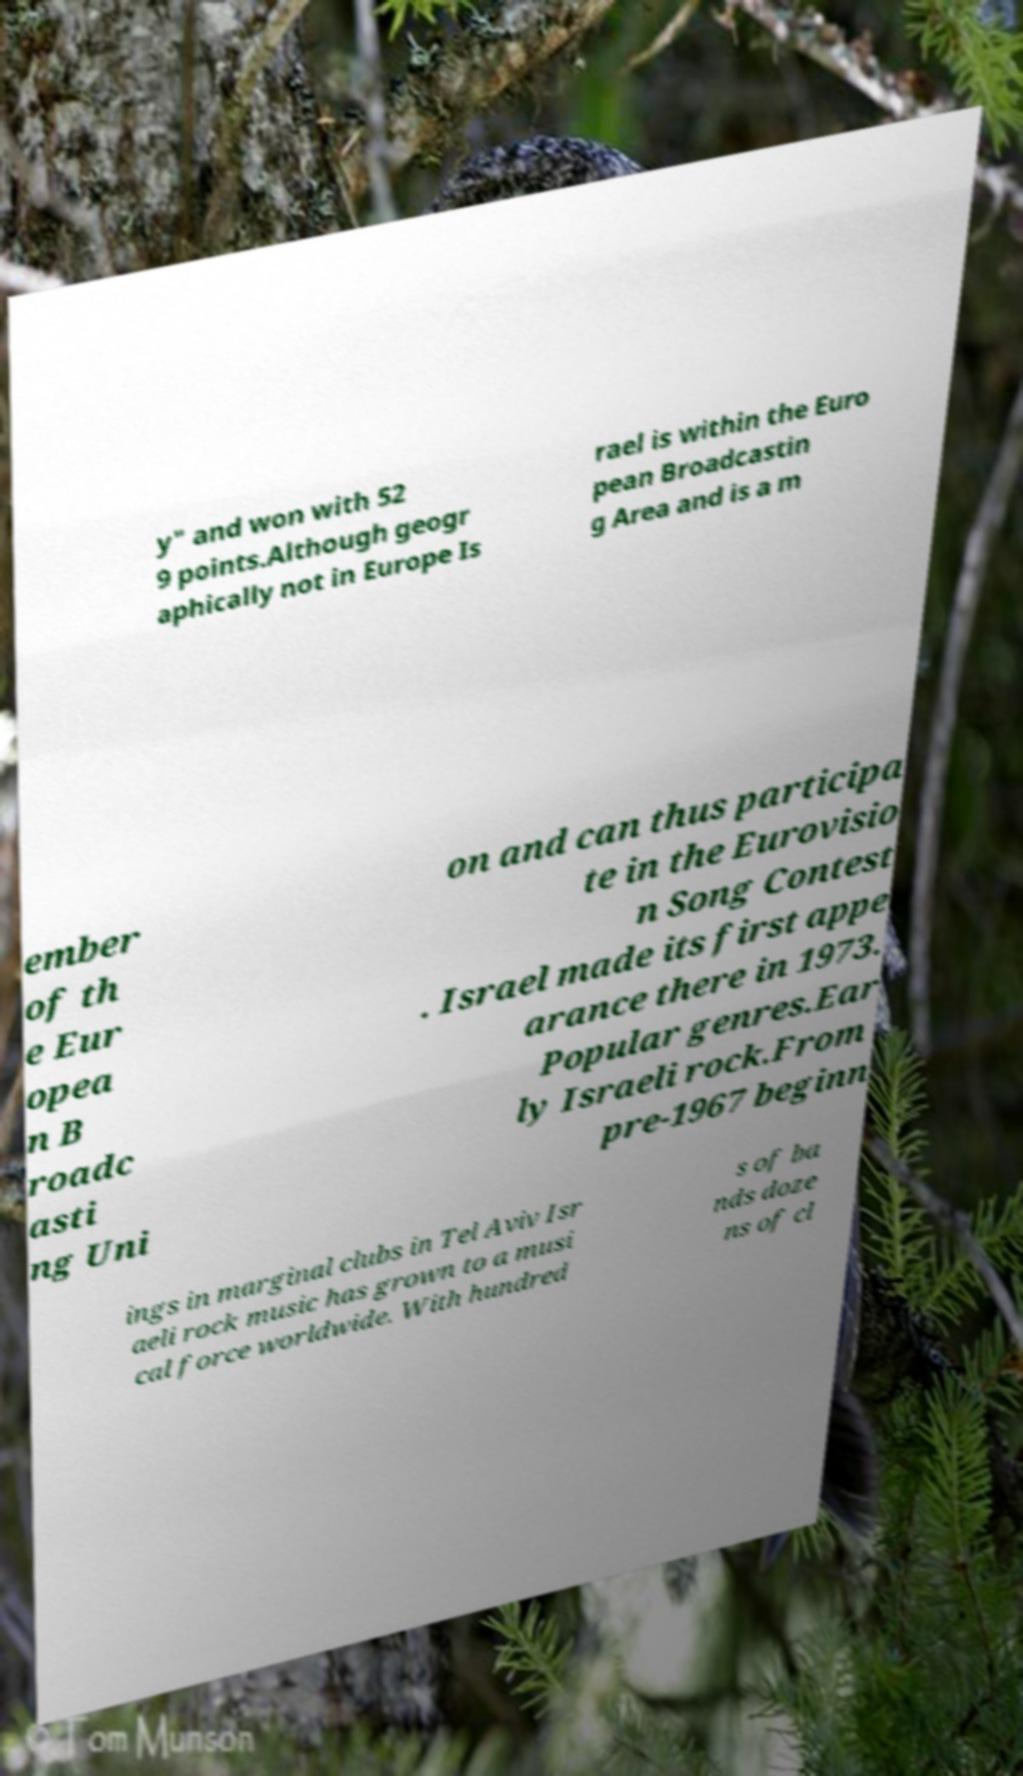For documentation purposes, I need the text within this image transcribed. Could you provide that? y" and won with 52 9 points.Although geogr aphically not in Europe Is rael is within the Euro pean Broadcastin g Area and is a m ember of th e Eur opea n B roadc asti ng Uni on and can thus participa te in the Eurovisio n Song Contest . Israel made its first appe arance there in 1973. Popular genres.Ear ly Israeli rock.From pre-1967 beginn ings in marginal clubs in Tel Aviv Isr aeli rock music has grown to a musi cal force worldwide. With hundred s of ba nds doze ns of cl 